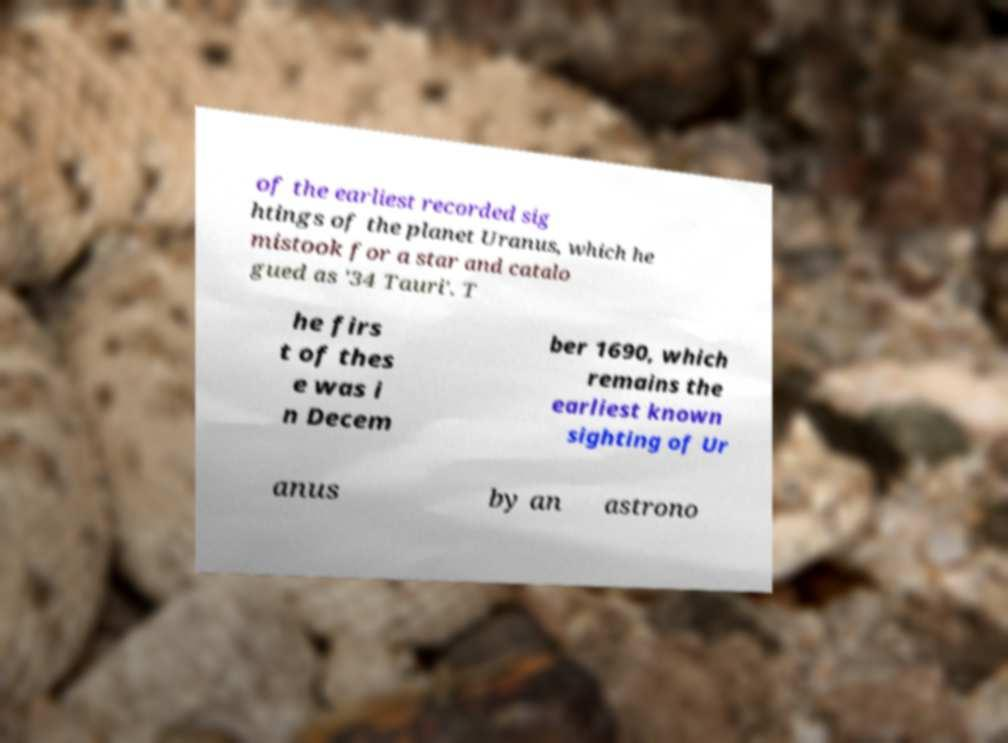For documentation purposes, I need the text within this image transcribed. Could you provide that? of the earliest recorded sig htings of the planet Uranus, which he mistook for a star and catalo gued as '34 Tauri'. T he firs t of thes e was i n Decem ber 1690, which remains the earliest known sighting of Ur anus by an astrono 